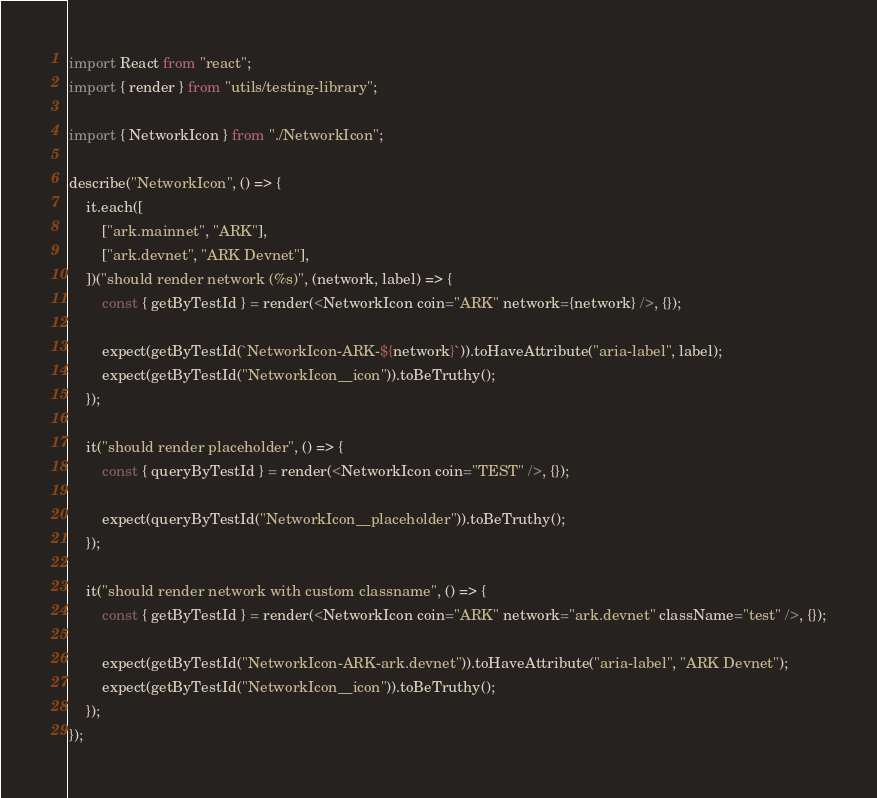Convert code to text. <code><loc_0><loc_0><loc_500><loc_500><_TypeScript_>import React from "react";
import { render } from "utils/testing-library";

import { NetworkIcon } from "./NetworkIcon";

describe("NetworkIcon", () => {
	it.each([
		["ark.mainnet", "ARK"],
		["ark.devnet", "ARK Devnet"],
	])("should render network (%s)", (network, label) => {
		const { getByTestId } = render(<NetworkIcon coin="ARK" network={network} />, {});

		expect(getByTestId(`NetworkIcon-ARK-${network}`)).toHaveAttribute("aria-label", label);
		expect(getByTestId("NetworkIcon__icon")).toBeTruthy();
	});

	it("should render placeholder", () => {
		const { queryByTestId } = render(<NetworkIcon coin="TEST" />, {});

		expect(queryByTestId("NetworkIcon__placeholder")).toBeTruthy();
	});

	it("should render network with custom classname", () => {
		const { getByTestId } = render(<NetworkIcon coin="ARK" network="ark.devnet" className="test" />, {});

		expect(getByTestId("NetworkIcon-ARK-ark.devnet")).toHaveAttribute("aria-label", "ARK Devnet");
		expect(getByTestId("NetworkIcon__icon")).toBeTruthy();
	});
});
</code> 